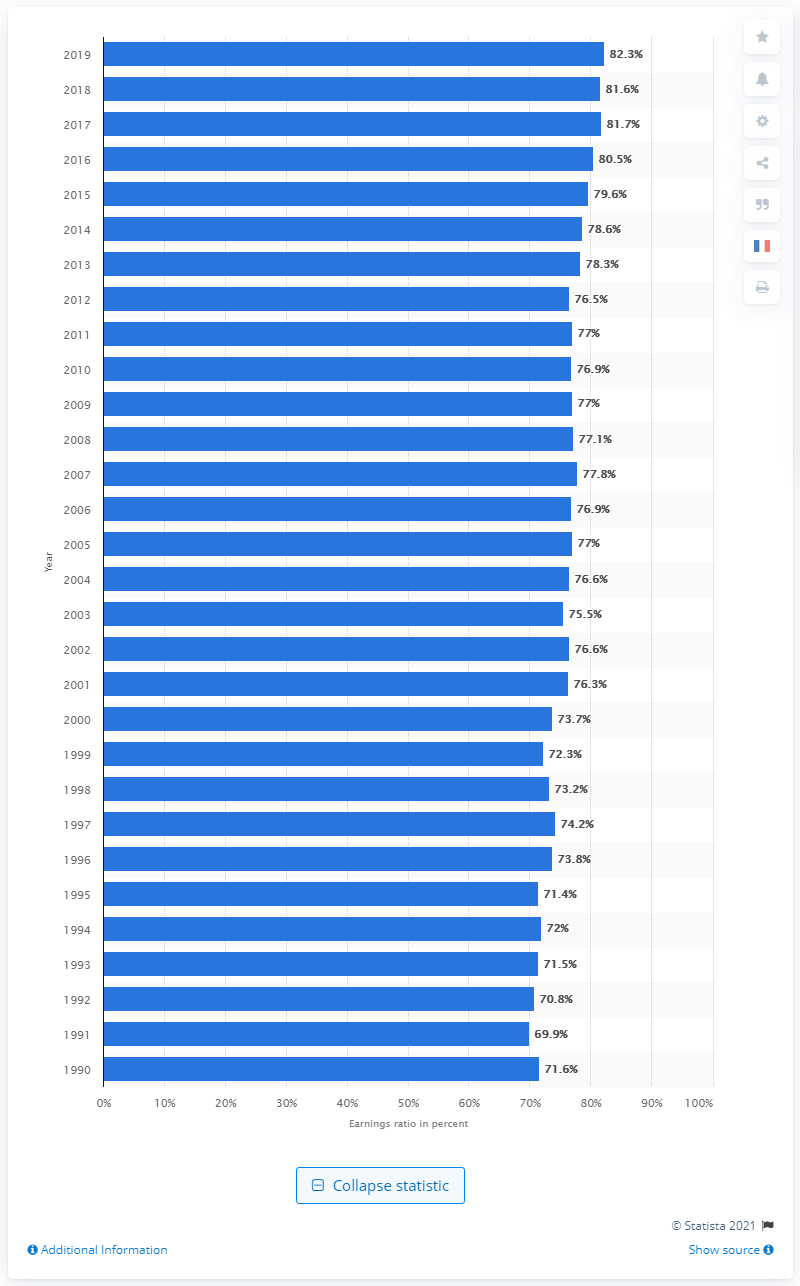Mention a couple of crucial points in this snapshot. The ratio in 2019 was 82.3%. 